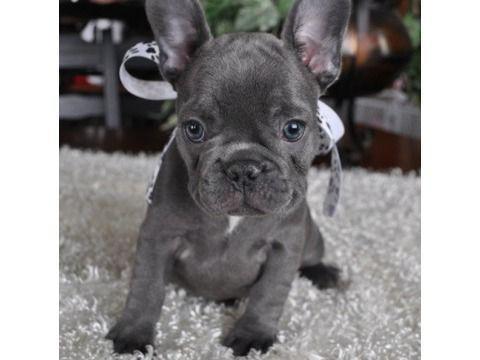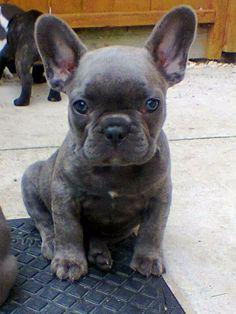The first image is the image on the left, the second image is the image on the right. Considering the images on both sides, is "One image includes exactly twice as many big-eared dogs in the foreground as the other image." valid? Answer yes or no. No. 